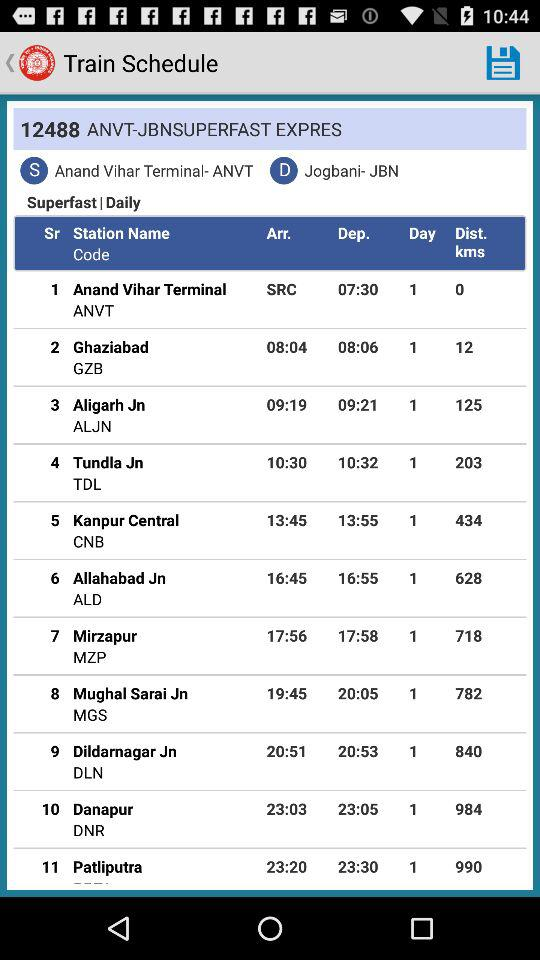What is the train number? The train number is 12488. 